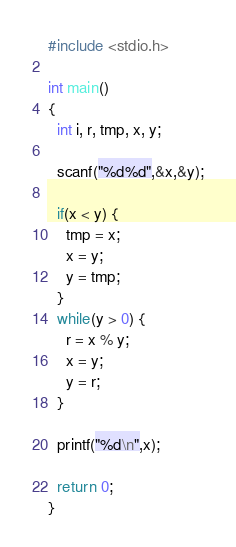<code> <loc_0><loc_0><loc_500><loc_500><_C_>#include <stdio.h>

int main()
{
  int i, r, tmp, x, y;

  scanf("%d%d",&x,&y);

  if(x < y) {
    tmp = x;
    x = y;
    y = tmp;
  }
  while(y > 0) {
    r = x % y;
    x = y;
    y = r;
  }
    
  printf("%d\n",x);

  return 0;
}


</code> 